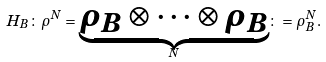<formula> <loc_0><loc_0><loc_500><loc_500>H _ { B } \colon \rho ^ { N } = \underset { N } { \underbrace { \rho _ { B } \otimes \cdots \otimes \rho _ { B } } } \colon = \rho _ { B } ^ { N } .</formula> 